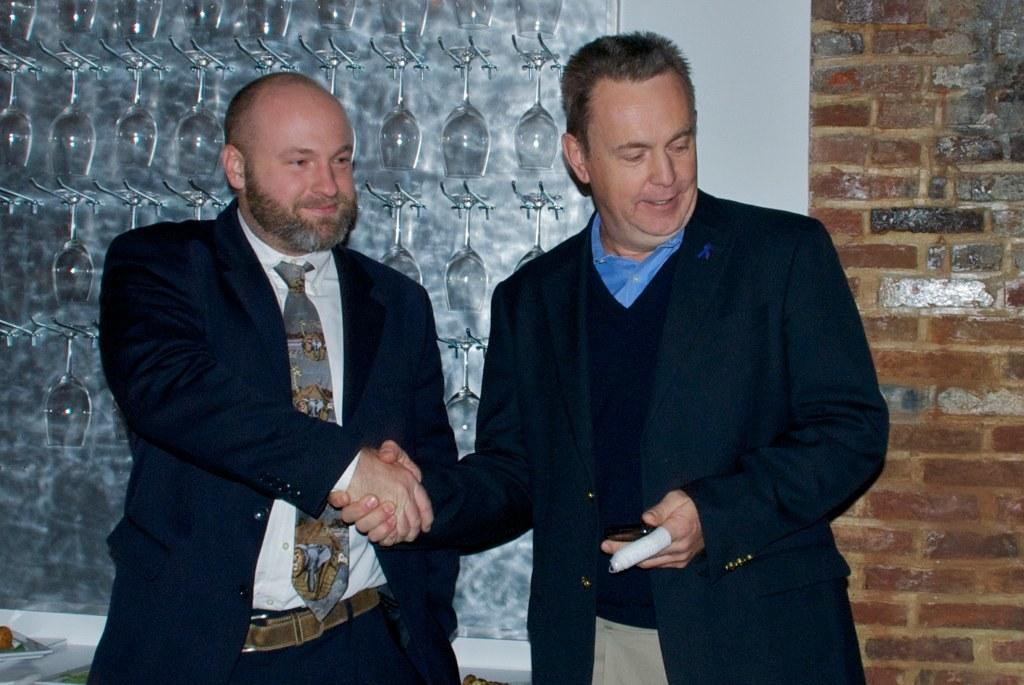How many people are in the foreground of the picture? There are two men in the foreground of the picture. What are the men wearing? The men are wearing suits. What are the men doing in the picture? The men are shaking hands. What can be seen in the background of the picture? There are glasses and a wall in the background of the picture. What type of attack is happening in the picture? There is no attack happening in the picture; the men are shaking hands. Where does the picture take place? The location is not specified in the image, so it cannot be determined from the picture. 